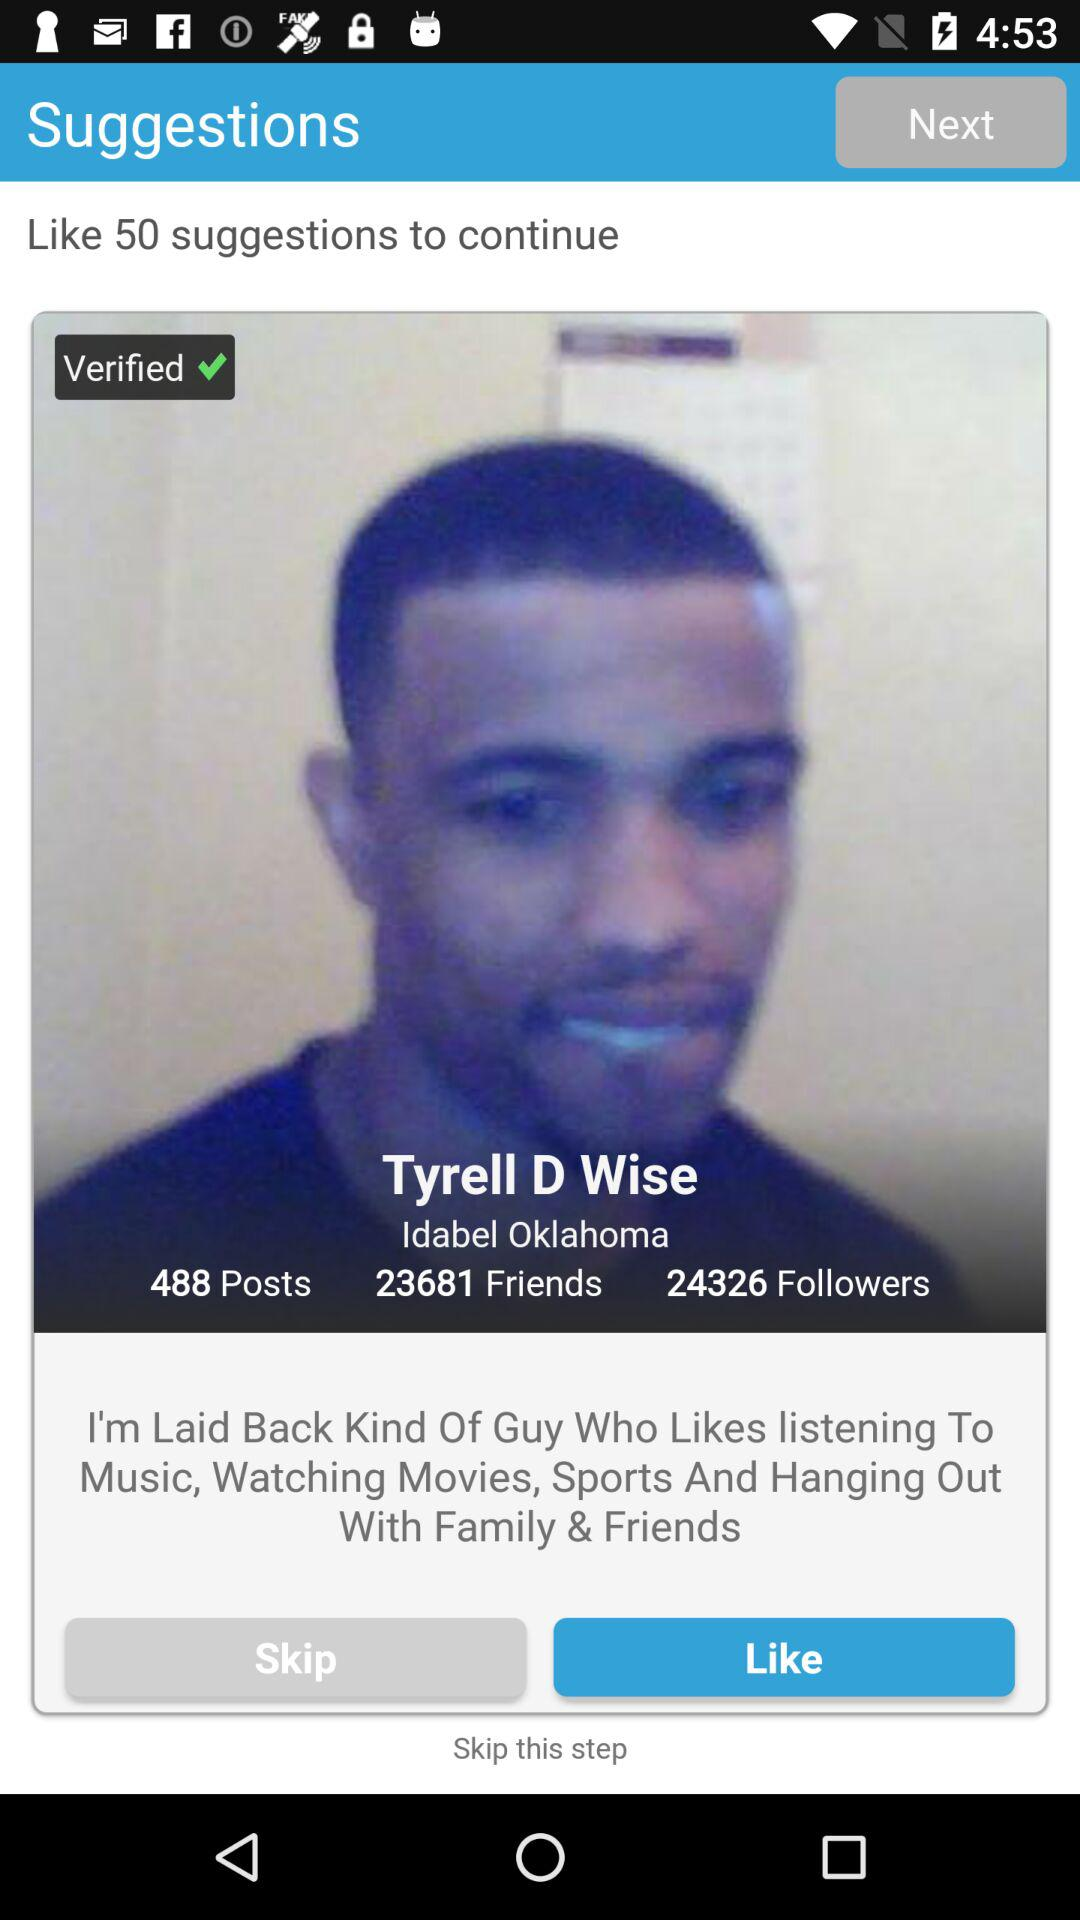What is the name of the user? The name of the user is Tyrell D Wise. 